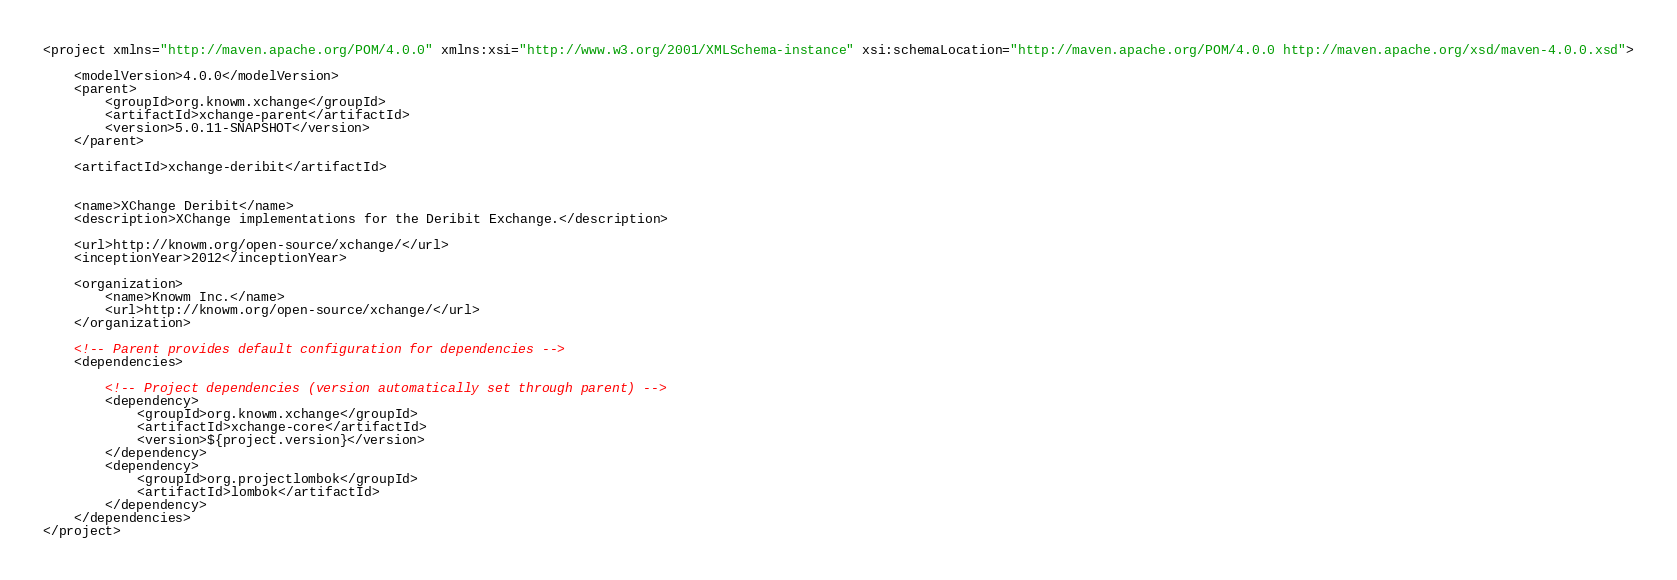Convert code to text. <code><loc_0><loc_0><loc_500><loc_500><_XML_><project xmlns="http://maven.apache.org/POM/4.0.0" xmlns:xsi="http://www.w3.org/2001/XMLSchema-instance" xsi:schemaLocation="http://maven.apache.org/POM/4.0.0 http://maven.apache.org/xsd/maven-4.0.0.xsd">

	<modelVersion>4.0.0</modelVersion>
	<parent>
		<groupId>org.knowm.xchange</groupId>
		<artifactId>xchange-parent</artifactId>
		<version>5.0.11-SNAPSHOT</version>
	</parent>

	<artifactId>xchange-deribit</artifactId>


	<name>XChange Deribit</name>
	<description>XChange implementations for the Deribit Exchange.</description>

	<url>http://knowm.org/open-source/xchange/</url>
	<inceptionYear>2012</inceptionYear>

	<organization>
		<name>Knowm Inc.</name>
		<url>http://knowm.org/open-source/xchange/</url>
	</organization>

	<!-- Parent provides default configuration for dependencies -->
	<dependencies>

		<!-- Project dependencies (version automatically set through parent) -->
		<dependency>
			<groupId>org.knowm.xchange</groupId>
			<artifactId>xchange-core</artifactId>
			<version>${project.version}</version>
		</dependency>
        <dependency>
            <groupId>org.projectlombok</groupId>
            <artifactId>lombok</artifactId>
        </dependency>
	</dependencies>
</project>
</code> 